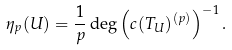Convert formula to latex. <formula><loc_0><loc_0><loc_500><loc_500>\eta _ { p } ( U ) = \frac { 1 } { p } \deg \left ( c ( T _ { U } ) ^ { ( p ) } \right ) ^ { - 1 } .</formula> 